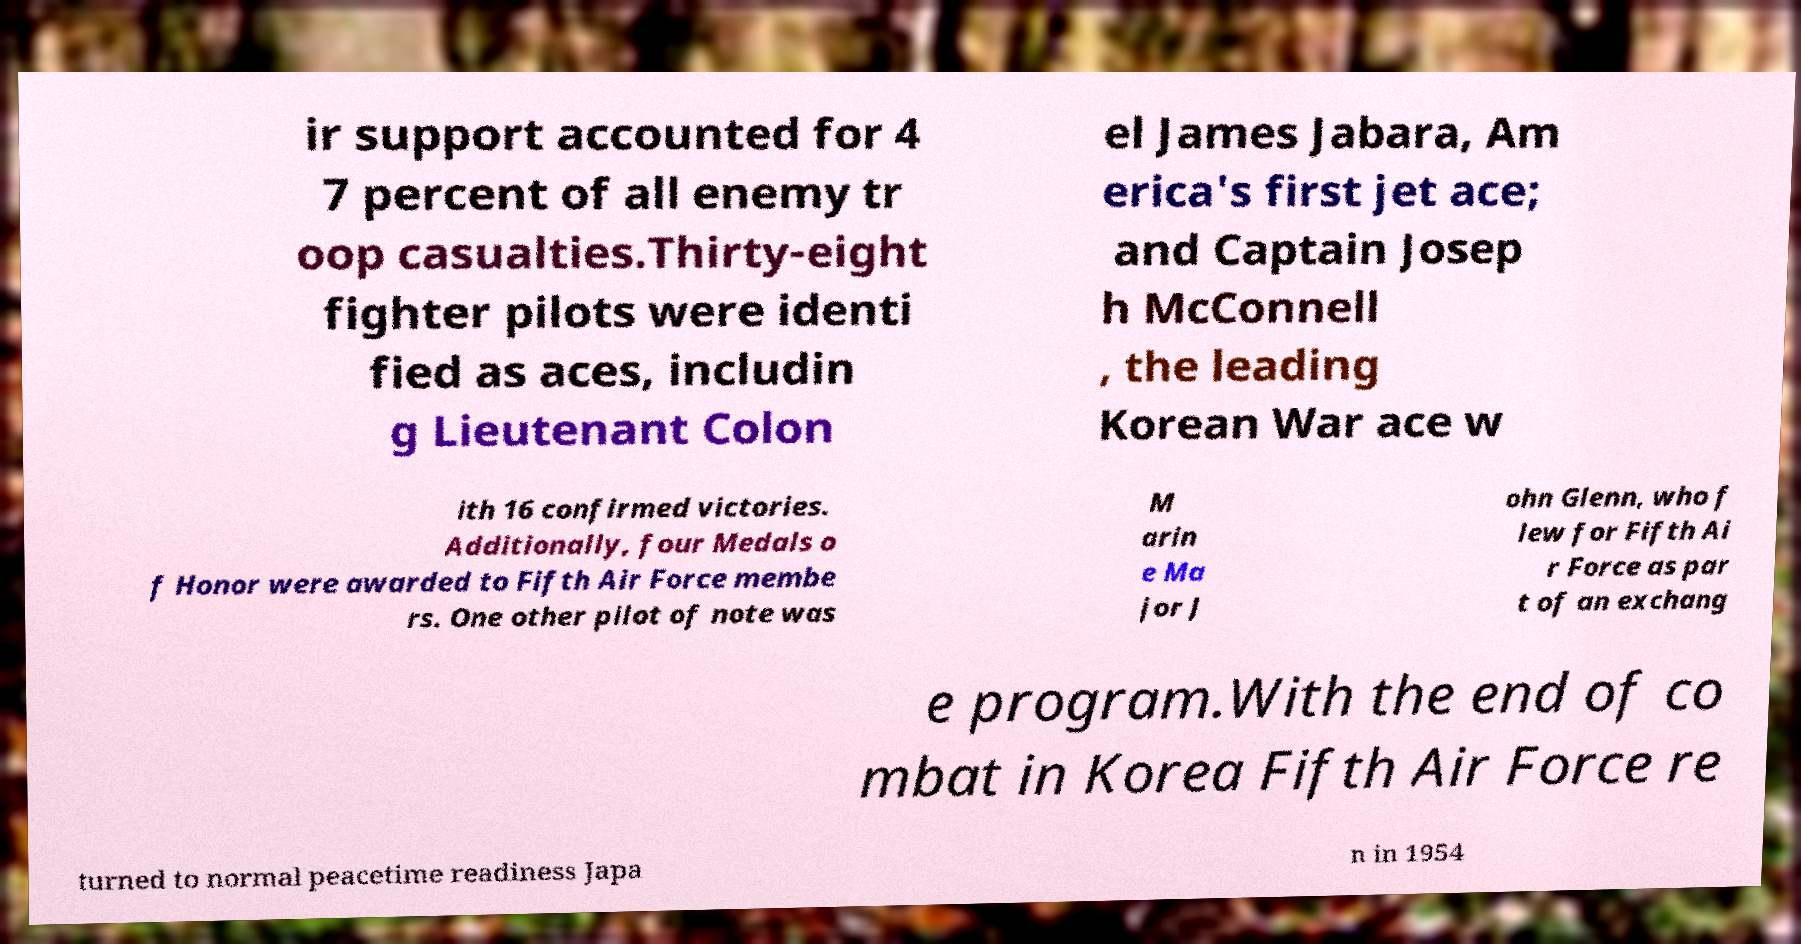There's text embedded in this image that I need extracted. Can you transcribe it verbatim? ir support accounted for 4 7 percent of all enemy tr oop casualties.Thirty-eight fighter pilots were identi fied as aces, includin g Lieutenant Colon el James Jabara, Am erica's first jet ace; and Captain Josep h McConnell , the leading Korean War ace w ith 16 confirmed victories. Additionally, four Medals o f Honor were awarded to Fifth Air Force membe rs. One other pilot of note was M arin e Ma jor J ohn Glenn, who f lew for Fifth Ai r Force as par t of an exchang e program.With the end of co mbat in Korea Fifth Air Force re turned to normal peacetime readiness Japa n in 1954 